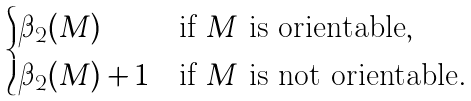<formula> <loc_0><loc_0><loc_500><loc_500>\begin{cases} \beta _ { 2 } ( M ) & \text {if $M$ is orientable} , \\ \beta _ { 2 } ( M ) + 1 & \text {if $M$ is not orientable} . \end{cases}</formula> 